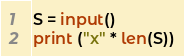<code> <loc_0><loc_0><loc_500><loc_500><_Python_>S = input()
print ("x" * len(S))</code> 